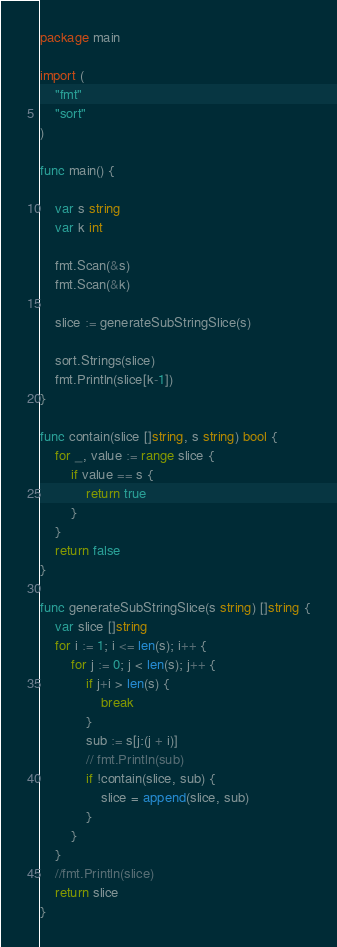Convert code to text. <code><loc_0><loc_0><loc_500><loc_500><_Go_>package main

import (
	"fmt"
	"sort"
)

func main() {

	var s string
	var k int

	fmt.Scan(&s)
	fmt.Scan(&k)

	slice := generateSubStringSlice(s)

	sort.Strings(slice)
	fmt.Println(slice[k-1])
}

func contain(slice []string, s string) bool {
	for _, value := range slice {
		if value == s {
			return true
		}
	}
	return false
}

func generateSubStringSlice(s string) []string {
	var slice []string
	for i := 1; i <= len(s); i++ {
		for j := 0; j < len(s); j++ {
			if j+i > len(s) {
				break
			}
			sub := s[j:(j + i)]
			// fmt.Println(sub)
			if !contain(slice, sub) {
				slice = append(slice, sub)
			}
		}
	}
	//fmt.Println(slice)
	return slice
}
</code> 